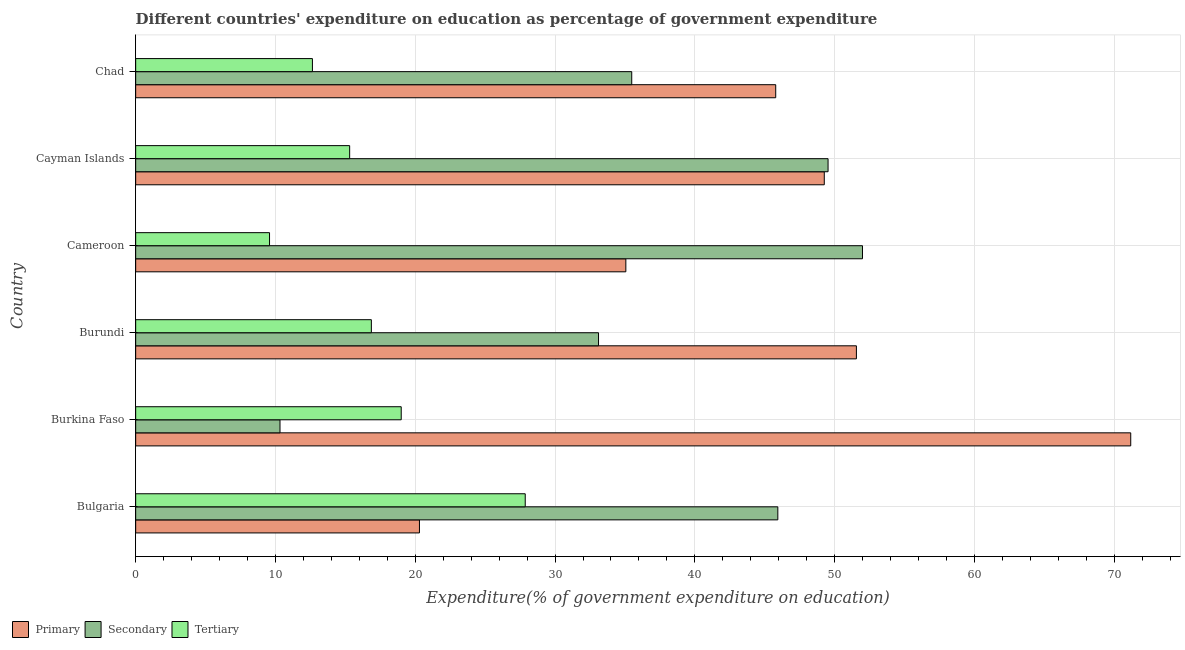Are the number of bars per tick equal to the number of legend labels?
Ensure brevity in your answer.  Yes. How many bars are there on the 6th tick from the top?
Keep it short and to the point. 3. What is the label of the 6th group of bars from the top?
Your response must be concise. Bulgaria. What is the expenditure on tertiary education in Chad?
Provide a short and direct response. 12.64. Across all countries, what is the maximum expenditure on secondary education?
Make the answer very short. 51.99. Across all countries, what is the minimum expenditure on secondary education?
Provide a succinct answer. 10.32. In which country was the expenditure on primary education maximum?
Offer a very short reply. Burkina Faso. What is the total expenditure on secondary education in the graph?
Give a very brief answer. 226.38. What is the difference between the expenditure on primary education in Bulgaria and that in Burundi?
Offer a terse response. -31.26. What is the difference between the expenditure on secondary education in Bulgaria and the expenditure on tertiary education in Cayman Islands?
Ensure brevity in your answer.  30.63. What is the average expenditure on tertiary education per country?
Provide a succinct answer. 16.88. What is the difference between the expenditure on secondary education and expenditure on tertiary education in Cameroon?
Give a very brief answer. 42.42. What is the ratio of the expenditure on tertiary education in Bulgaria to that in Burundi?
Give a very brief answer. 1.65. Is the expenditure on secondary education in Burundi less than that in Cameroon?
Your answer should be very brief. Yes. What is the difference between the highest and the second highest expenditure on secondary education?
Make the answer very short. 2.46. What is the difference between the highest and the lowest expenditure on primary education?
Make the answer very short. 50.88. Is the sum of the expenditure on secondary education in Bulgaria and Chad greater than the maximum expenditure on tertiary education across all countries?
Ensure brevity in your answer.  Yes. What does the 1st bar from the top in Cameroon represents?
Your answer should be very brief. Tertiary. What does the 3rd bar from the bottom in Cayman Islands represents?
Offer a very short reply. Tertiary. Does the graph contain grids?
Ensure brevity in your answer.  Yes. What is the title of the graph?
Your answer should be compact. Different countries' expenditure on education as percentage of government expenditure. What is the label or title of the X-axis?
Make the answer very short. Expenditure(% of government expenditure on education). What is the label or title of the Y-axis?
Provide a succinct answer. Country. What is the Expenditure(% of government expenditure on education) of Primary in Bulgaria?
Your answer should be very brief. 20.3. What is the Expenditure(% of government expenditure on education) of Secondary in Bulgaria?
Your answer should be very brief. 45.94. What is the Expenditure(% of government expenditure on education) of Tertiary in Bulgaria?
Provide a short and direct response. 27.87. What is the Expenditure(% of government expenditure on education) in Primary in Burkina Faso?
Your answer should be compact. 71.18. What is the Expenditure(% of government expenditure on education) of Secondary in Burkina Faso?
Offer a very short reply. 10.32. What is the Expenditure(% of government expenditure on education) of Tertiary in Burkina Faso?
Your response must be concise. 19. What is the Expenditure(% of government expenditure on education) in Primary in Burundi?
Offer a terse response. 51.56. What is the Expenditure(% of government expenditure on education) in Secondary in Burundi?
Your answer should be compact. 33.11. What is the Expenditure(% of government expenditure on education) in Tertiary in Burundi?
Make the answer very short. 16.86. What is the Expenditure(% of government expenditure on education) of Primary in Cameroon?
Keep it short and to the point. 35.06. What is the Expenditure(% of government expenditure on education) in Secondary in Cameroon?
Offer a very short reply. 51.99. What is the Expenditure(% of government expenditure on education) in Tertiary in Cameroon?
Your answer should be very brief. 9.58. What is the Expenditure(% of government expenditure on education) in Primary in Cayman Islands?
Provide a short and direct response. 49.26. What is the Expenditure(% of government expenditure on education) in Secondary in Cayman Islands?
Your response must be concise. 49.53. What is the Expenditure(% of government expenditure on education) in Tertiary in Cayman Islands?
Your response must be concise. 15.31. What is the Expenditure(% of government expenditure on education) in Primary in Chad?
Make the answer very short. 45.78. What is the Expenditure(% of government expenditure on education) of Secondary in Chad?
Ensure brevity in your answer.  35.48. What is the Expenditure(% of government expenditure on education) of Tertiary in Chad?
Offer a very short reply. 12.64. Across all countries, what is the maximum Expenditure(% of government expenditure on education) of Primary?
Your answer should be very brief. 71.18. Across all countries, what is the maximum Expenditure(% of government expenditure on education) in Secondary?
Keep it short and to the point. 51.99. Across all countries, what is the maximum Expenditure(% of government expenditure on education) in Tertiary?
Offer a very short reply. 27.87. Across all countries, what is the minimum Expenditure(% of government expenditure on education) in Primary?
Your response must be concise. 20.3. Across all countries, what is the minimum Expenditure(% of government expenditure on education) of Secondary?
Provide a short and direct response. 10.32. Across all countries, what is the minimum Expenditure(% of government expenditure on education) in Tertiary?
Make the answer very short. 9.58. What is the total Expenditure(% of government expenditure on education) in Primary in the graph?
Provide a short and direct response. 273.15. What is the total Expenditure(% of government expenditure on education) of Secondary in the graph?
Keep it short and to the point. 226.38. What is the total Expenditure(% of government expenditure on education) of Tertiary in the graph?
Make the answer very short. 101.25. What is the difference between the Expenditure(% of government expenditure on education) in Primary in Bulgaria and that in Burkina Faso?
Your answer should be very brief. -50.88. What is the difference between the Expenditure(% of government expenditure on education) in Secondary in Bulgaria and that in Burkina Faso?
Your answer should be very brief. 35.61. What is the difference between the Expenditure(% of government expenditure on education) in Tertiary in Bulgaria and that in Burkina Faso?
Keep it short and to the point. 8.87. What is the difference between the Expenditure(% of government expenditure on education) of Primary in Bulgaria and that in Burundi?
Offer a terse response. -31.26. What is the difference between the Expenditure(% of government expenditure on education) in Secondary in Bulgaria and that in Burundi?
Give a very brief answer. 12.83. What is the difference between the Expenditure(% of government expenditure on education) in Tertiary in Bulgaria and that in Burundi?
Your response must be concise. 11.01. What is the difference between the Expenditure(% of government expenditure on education) of Primary in Bulgaria and that in Cameroon?
Ensure brevity in your answer.  -14.76. What is the difference between the Expenditure(% of government expenditure on education) in Secondary in Bulgaria and that in Cameroon?
Your answer should be very brief. -6.06. What is the difference between the Expenditure(% of government expenditure on education) of Tertiary in Bulgaria and that in Cameroon?
Your answer should be very brief. 18.29. What is the difference between the Expenditure(% of government expenditure on education) in Primary in Bulgaria and that in Cayman Islands?
Provide a succinct answer. -28.96. What is the difference between the Expenditure(% of government expenditure on education) in Secondary in Bulgaria and that in Cayman Islands?
Provide a short and direct response. -3.59. What is the difference between the Expenditure(% of government expenditure on education) in Tertiary in Bulgaria and that in Cayman Islands?
Offer a terse response. 12.56. What is the difference between the Expenditure(% of government expenditure on education) in Primary in Bulgaria and that in Chad?
Offer a terse response. -25.48. What is the difference between the Expenditure(% of government expenditure on education) in Secondary in Bulgaria and that in Chad?
Offer a very short reply. 10.45. What is the difference between the Expenditure(% of government expenditure on education) of Tertiary in Bulgaria and that in Chad?
Offer a terse response. 15.22. What is the difference between the Expenditure(% of government expenditure on education) in Primary in Burkina Faso and that in Burundi?
Your answer should be compact. 19.62. What is the difference between the Expenditure(% of government expenditure on education) of Secondary in Burkina Faso and that in Burundi?
Ensure brevity in your answer.  -22.79. What is the difference between the Expenditure(% of government expenditure on education) in Tertiary in Burkina Faso and that in Burundi?
Your answer should be compact. 2.14. What is the difference between the Expenditure(% of government expenditure on education) of Primary in Burkina Faso and that in Cameroon?
Your answer should be very brief. 36.12. What is the difference between the Expenditure(% of government expenditure on education) in Secondary in Burkina Faso and that in Cameroon?
Give a very brief answer. -41.67. What is the difference between the Expenditure(% of government expenditure on education) in Tertiary in Burkina Faso and that in Cameroon?
Offer a terse response. 9.42. What is the difference between the Expenditure(% of government expenditure on education) of Primary in Burkina Faso and that in Cayman Islands?
Provide a short and direct response. 21.92. What is the difference between the Expenditure(% of government expenditure on education) in Secondary in Burkina Faso and that in Cayman Islands?
Your answer should be compact. -39.2. What is the difference between the Expenditure(% of government expenditure on education) of Tertiary in Burkina Faso and that in Cayman Islands?
Provide a succinct answer. 3.69. What is the difference between the Expenditure(% of government expenditure on education) of Primary in Burkina Faso and that in Chad?
Provide a succinct answer. 25.4. What is the difference between the Expenditure(% of government expenditure on education) in Secondary in Burkina Faso and that in Chad?
Your answer should be very brief. -25.16. What is the difference between the Expenditure(% of government expenditure on education) in Tertiary in Burkina Faso and that in Chad?
Your answer should be very brief. 6.35. What is the difference between the Expenditure(% of government expenditure on education) of Primary in Burundi and that in Cameroon?
Make the answer very short. 16.49. What is the difference between the Expenditure(% of government expenditure on education) of Secondary in Burundi and that in Cameroon?
Keep it short and to the point. -18.88. What is the difference between the Expenditure(% of government expenditure on education) in Tertiary in Burundi and that in Cameroon?
Keep it short and to the point. 7.28. What is the difference between the Expenditure(% of government expenditure on education) of Primary in Burundi and that in Cayman Islands?
Make the answer very short. 2.3. What is the difference between the Expenditure(% of government expenditure on education) in Secondary in Burundi and that in Cayman Islands?
Offer a terse response. -16.42. What is the difference between the Expenditure(% of government expenditure on education) of Tertiary in Burundi and that in Cayman Islands?
Your answer should be very brief. 1.55. What is the difference between the Expenditure(% of government expenditure on education) of Primary in Burundi and that in Chad?
Offer a terse response. 5.77. What is the difference between the Expenditure(% of government expenditure on education) in Secondary in Burundi and that in Chad?
Your response must be concise. -2.38. What is the difference between the Expenditure(% of government expenditure on education) in Tertiary in Burundi and that in Chad?
Your response must be concise. 4.22. What is the difference between the Expenditure(% of government expenditure on education) in Primary in Cameroon and that in Cayman Islands?
Offer a terse response. -14.19. What is the difference between the Expenditure(% of government expenditure on education) in Secondary in Cameroon and that in Cayman Islands?
Your answer should be very brief. 2.46. What is the difference between the Expenditure(% of government expenditure on education) of Tertiary in Cameroon and that in Cayman Islands?
Make the answer very short. -5.73. What is the difference between the Expenditure(% of government expenditure on education) of Primary in Cameroon and that in Chad?
Keep it short and to the point. -10.72. What is the difference between the Expenditure(% of government expenditure on education) of Secondary in Cameroon and that in Chad?
Offer a very short reply. 16.51. What is the difference between the Expenditure(% of government expenditure on education) in Tertiary in Cameroon and that in Chad?
Your answer should be very brief. -3.07. What is the difference between the Expenditure(% of government expenditure on education) of Primary in Cayman Islands and that in Chad?
Ensure brevity in your answer.  3.47. What is the difference between the Expenditure(% of government expenditure on education) in Secondary in Cayman Islands and that in Chad?
Give a very brief answer. 14.04. What is the difference between the Expenditure(% of government expenditure on education) in Tertiary in Cayman Islands and that in Chad?
Provide a succinct answer. 2.66. What is the difference between the Expenditure(% of government expenditure on education) of Primary in Bulgaria and the Expenditure(% of government expenditure on education) of Secondary in Burkina Faso?
Ensure brevity in your answer.  9.98. What is the difference between the Expenditure(% of government expenditure on education) in Primary in Bulgaria and the Expenditure(% of government expenditure on education) in Tertiary in Burkina Faso?
Give a very brief answer. 1.3. What is the difference between the Expenditure(% of government expenditure on education) in Secondary in Bulgaria and the Expenditure(% of government expenditure on education) in Tertiary in Burkina Faso?
Your answer should be very brief. 26.94. What is the difference between the Expenditure(% of government expenditure on education) in Primary in Bulgaria and the Expenditure(% of government expenditure on education) in Secondary in Burundi?
Provide a succinct answer. -12.81. What is the difference between the Expenditure(% of government expenditure on education) of Primary in Bulgaria and the Expenditure(% of government expenditure on education) of Tertiary in Burundi?
Offer a very short reply. 3.44. What is the difference between the Expenditure(% of government expenditure on education) of Secondary in Bulgaria and the Expenditure(% of government expenditure on education) of Tertiary in Burundi?
Your response must be concise. 29.08. What is the difference between the Expenditure(% of government expenditure on education) of Primary in Bulgaria and the Expenditure(% of government expenditure on education) of Secondary in Cameroon?
Give a very brief answer. -31.69. What is the difference between the Expenditure(% of government expenditure on education) in Primary in Bulgaria and the Expenditure(% of government expenditure on education) in Tertiary in Cameroon?
Your answer should be very brief. 10.72. What is the difference between the Expenditure(% of government expenditure on education) of Secondary in Bulgaria and the Expenditure(% of government expenditure on education) of Tertiary in Cameroon?
Your answer should be very brief. 36.36. What is the difference between the Expenditure(% of government expenditure on education) in Primary in Bulgaria and the Expenditure(% of government expenditure on education) in Secondary in Cayman Islands?
Your answer should be compact. -29.23. What is the difference between the Expenditure(% of government expenditure on education) of Primary in Bulgaria and the Expenditure(% of government expenditure on education) of Tertiary in Cayman Islands?
Your answer should be very brief. 4.99. What is the difference between the Expenditure(% of government expenditure on education) in Secondary in Bulgaria and the Expenditure(% of government expenditure on education) in Tertiary in Cayman Islands?
Provide a succinct answer. 30.63. What is the difference between the Expenditure(% of government expenditure on education) in Primary in Bulgaria and the Expenditure(% of government expenditure on education) in Secondary in Chad?
Your answer should be compact. -15.18. What is the difference between the Expenditure(% of government expenditure on education) of Primary in Bulgaria and the Expenditure(% of government expenditure on education) of Tertiary in Chad?
Your response must be concise. 7.66. What is the difference between the Expenditure(% of government expenditure on education) in Secondary in Bulgaria and the Expenditure(% of government expenditure on education) in Tertiary in Chad?
Provide a succinct answer. 33.29. What is the difference between the Expenditure(% of government expenditure on education) of Primary in Burkina Faso and the Expenditure(% of government expenditure on education) of Secondary in Burundi?
Offer a very short reply. 38.07. What is the difference between the Expenditure(% of government expenditure on education) in Primary in Burkina Faso and the Expenditure(% of government expenditure on education) in Tertiary in Burundi?
Ensure brevity in your answer.  54.32. What is the difference between the Expenditure(% of government expenditure on education) of Secondary in Burkina Faso and the Expenditure(% of government expenditure on education) of Tertiary in Burundi?
Make the answer very short. -6.53. What is the difference between the Expenditure(% of government expenditure on education) in Primary in Burkina Faso and the Expenditure(% of government expenditure on education) in Secondary in Cameroon?
Give a very brief answer. 19.19. What is the difference between the Expenditure(% of government expenditure on education) of Primary in Burkina Faso and the Expenditure(% of government expenditure on education) of Tertiary in Cameroon?
Provide a succinct answer. 61.61. What is the difference between the Expenditure(% of government expenditure on education) in Secondary in Burkina Faso and the Expenditure(% of government expenditure on education) in Tertiary in Cameroon?
Give a very brief answer. 0.75. What is the difference between the Expenditure(% of government expenditure on education) of Primary in Burkina Faso and the Expenditure(% of government expenditure on education) of Secondary in Cayman Islands?
Give a very brief answer. 21.65. What is the difference between the Expenditure(% of government expenditure on education) of Primary in Burkina Faso and the Expenditure(% of government expenditure on education) of Tertiary in Cayman Islands?
Provide a short and direct response. 55.87. What is the difference between the Expenditure(% of government expenditure on education) of Secondary in Burkina Faso and the Expenditure(% of government expenditure on education) of Tertiary in Cayman Islands?
Keep it short and to the point. -4.98. What is the difference between the Expenditure(% of government expenditure on education) in Primary in Burkina Faso and the Expenditure(% of government expenditure on education) in Secondary in Chad?
Your answer should be very brief. 35.7. What is the difference between the Expenditure(% of government expenditure on education) in Primary in Burkina Faso and the Expenditure(% of government expenditure on education) in Tertiary in Chad?
Give a very brief answer. 58.54. What is the difference between the Expenditure(% of government expenditure on education) of Secondary in Burkina Faso and the Expenditure(% of government expenditure on education) of Tertiary in Chad?
Make the answer very short. -2.32. What is the difference between the Expenditure(% of government expenditure on education) in Primary in Burundi and the Expenditure(% of government expenditure on education) in Secondary in Cameroon?
Your answer should be compact. -0.43. What is the difference between the Expenditure(% of government expenditure on education) of Primary in Burundi and the Expenditure(% of government expenditure on education) of Tertiary in Cameroon?
Ensure brevity in your answer.  41.98. What is the difference between the Expenditure(% of government expenditure on education) in Secondary in Burundi and the Expenditure(% of government expenditure on education) in Tertiary in Cameroon?
Make the answer very short. 23.53. What is the difference between the Expenditure(% of government expenditure on education) in Primary in Burundi and the Expenditure(% of government expenditure on education) in Secondary in Cayman Islands?
Offer a very short reply. 2.03. What is the difference between the Expenditure(% of government expenditure on education) of Primary in Burundi and the Expenditure(% of government expenditure on education) of Tertiary in Cayman Islands?
Keep it short and to the point. 36.25. What is the difference between the Expenditure(% of government expenditure on education) of Secondary in Burundi and the Expenditure(% of government expenditure on education) of Tertiary in Cayman Islands?
Offer a terse response. 17.8. What is the difference between the Expenditure(% of government expenditure on education) in Primary in Burundi and the Expenditure(% of government expenditure on education) in Secondary in Chad?
Offer a terse response. 16.07. What is the difference between the Expenditure(% of government expenditure on education) in Primary in Burundi and the Expenditure(% of government expenditure on education) in Tertiary in Chad?
Ensure brevity in your answer.  38.91. What is the difference between the Expenditure(% of government expenditure on education) in Secondary in Burundi and the Expenditure(% of government expenditure on education) in Tertiary in Chad?
Your answer should be very brief. 20.47. What is the difference between the Expenditure(% of government expenditure on education) in Primary in Cameroon and the Expenditure(% of government expenditure on education) in Secondary in Cayman Islands?
Offer a very short reply. -14.47. What is the difference between the Expenditure(% of government expenditure on education) of Primary in Cameroon and the Expenditure(% of government expenditure on education) of Tertiary in Cayman Islands?
Provide a short and direct response. 19.76. What is the difference between the Expenditure(% of government expenditure on education) in Secondary in Cameroon and the Expenditure(% of government expenditure on education) in Tertiary in Cayman Islands?
Provide a short and direct response. 36.68. What is the difference between the Expenditure(% of government expenditure on education) in Primary in Cameroon and the Expenditure(% of government expenditure on education) in Secondary in Chad?
Your answer should be very brief. -0.42. What is the difference between the Expenditure(% of government expenditure on education) in Primary in Cameroon and the Expenditure(% of government expenditure on education) in Tertiary in Chad?
Offer a terse response. 22.42. What is the difference between the Expenditure(% of government expenditure on education) in Secondary in Cameroon and the Expenditure(% of government expenditure on education) in Tertiary in Chad?
Your answer should be very brief. 39.35. What is the difference between the Expenditure(% of government expenditure on education) in Primary in Cayman Islands and the Expenditure(% of government expenditure on education) in Secondary in Chad?
Your answer should be very brief. 13.77. What is the difference between the Expenditure(% of government expenditure on education) of Primary in Cayman Islands and the Expenditure(% of government expenditure on education) of Tertiary in Chad?
Provide a short and direct response. 36.62. What is the difference between the Expenditure(% of government expenditure on education) in Secondary in Cayman Islands and the Expenditure(% of government expenditure on education) in Tertiary in Chad?
Make the answer very short. 36.89. What is the average Expenditure(% of government expenditure on education) of Primary per country?
Ensure brevity in your answer.  45.52. What is the average Expenditure(% of government expenditure on education) in Secondary per country?
Your response must be concise. 37.73. What is the average Expenditure(% of government expenditure on education) of Tertiary per country?
Ensure brevity in your answer.  16.87. What is the difference between the Expenditure(% of government expenditure on education) in Primary and Expenditure(% of government expenditure on education) in Secondary in Bulgaria?
Make the answer very short. -25.64. What is the difference between the Expenditure(% of government expenditure on education) of Primary and Expenditure(% of government expenditure on education) of Tertiary in Bulgaria?
Your response must be concise. -7.57. What is the difference between the Expenditure(% of government expenditure on education) in Secondary and Expenditure(% of government expenditure on education) in Tertiary in Bulgaria?
Ensure brevity in your answer.  18.07. What is the difference between the Expenditure(% of government expenditure on education) in Primary and Expenditure(% of government expenditure on education) in Secondary in Burkina Faso?
Offer a terse response. 60.86. What is the difference between the Expenditure(% of government expenditure on education) of Primary and Expenditure(% of government expenditure on education) of Tertiary in Burkina Faso?
Your answer should be very brief. 52.19. What is the difference between the Expenditure(% of government expenditure on education) in Secondary and Expenditure(% of government expenditure on education) in Tertiary in Burkina Faso?
Give a very brief answer. -8.67. What is the difference between the Expenditure(% of government expenditure on education) in Primary and Expenditure(% of government expenditure on education) in Secondary in Burundi?
Give a very brief answer. 18.45. What is the difference between the Expenditure(% of government expenditure on education) in Primary and Expenditure(% of government expenditure on education) in Tertiary in Burundi?
Provide a succinct answer. 34.7. What is the difference between the Expenditure(% of government expenditure on education) of Secondary and Expenditure(% of government expenditure on education) of Tertiary in Burundi?
Your response must be concise. 16.25. What is the difference between the Expenditure(% of government expenditure on education) of Primary and Expenditure(% of government expenditure on education) of Secondary in Cameroon?
Provide a short and direct response. -16.93. What is the difference between the Expenditure(% of government expenditure on education) in Primary and Expenditure(% of government expenditure on education) in Tertiary in Cameroon?
Your answer should be very brief. 25.49. What is the difference between the Expenditure(% of government expenditure on education) of Secondary and Expenditure(% of government expenditure on education) of Tertiary in Cameroon?
Ensure brevity in your answer.  42.42. What is the difference between the Expenditure(% of government expenditure on education) in Primary and Expenditure(% of government expenditure on education) in Secondary in Cayman Islands?
Offer a very short reply. -0.27. What is the difference between the Expenditure(% of government expenditure on education) of Primary and Expenditure(% of government expenditure on education) of Tertiary in Cayman Islands?
Make the answer very short. 33.95. What is the difference between the Expenditure(% of government expenditure on education) in Secondary and Expenditure(% of government expenditure on education) in Tertiary in Cayman Islands?
Your answer should be very brief. 34.22. What is the difference between the Expenditure(% of government expenditure on education) in Primary and Expenditure(% of government expenditure on education) in Secondary in Chad?
Offer a terse response. 10.3. What is the difference between the Expenditure(% of government expenditure on education) of Primary and Expenditure(% of government expenditure on education) of Tertiary in Chad?
Your answer should be compact. 33.14. What is the difference between the Expenditure(% of government expenditure on education) in Secondary and Expenditure(% of government expenditure on education) in Tertiary in Chad?
Ensure brevity in your answer.  22.84. What is the ratio of the Expenditure(% of government expenditure on education) of Primary in Bulgaria to that in Burkina Faso?
Your answer should be compact. 0.29. What is the ratio of the Expenditure(% of government expenditure on education) in Secondary in Bulgaria to that in Burkina Faso?
Make the answer very short. 4.45. What is the ratio of the Expenditure(% of government expenditure on education) of Tertiary in Bulgaria to that in Burkina Faso?
Provide a short and direct response. 1.47. What is the ratio of the Expenditure(% of government expenditure on education) of Primary in Bulgaria to that in Burundi?
Make the answer very short. 0.39. What is the ratio of the Expenditure(% of government expenditure on education) of Secondary in Bulgaria to that in Burundi?
Provide a succinct answer. 1.39. What is the ratio of the Expenditure(% of government expenditure on education) in Tertiary in Bulgaria to that in Burundi?
Offer a very short reply. 1.65. What is the ratio of the Expenditure(% of government expenditure on education) in Primary in Bulgaria to that in Cameroon?
Your answer should be very brief. 0.58. What is the ratio of the Expenditure(% of government expenditure on education) of Secondary in Bulgaria to that in Cameroon?
Provide a succinct answer. 0.88. What is the ratio of the Expenditure(% of government expenditure on education) of Tertiary in Bulgaria to that in Cameroon?
Make the answer very short. 2.91. What is the ratio of the Expenditure(% of government expenditure on education) in Primary in Bulgaria to that in Cayman Islands?
Offer a terse response. 0.41. What is the ratio of the Expenditure(% of government expenditure on education) in Secondary in Bulgaria to that in Cayman Islands?
Your answer should be compact. 0.93. What is the ratio of the Expenditure(% of government expenditure on education) of Tertiary in Bulgaria to that in Cayman Islands?
Give a very brief answer. 1.82. What is the ratio of the Expenditure(% of government expenditure on education) of Primary in Bulgaria to that in Chad?
Your response must be concise. 0.44. What is the ratio of the Expenditure(% of government expenditure on education) of Secondary in Bulgaria to that in Chad?
Ensure brevity in your answer.  1.29. What is the ratio of the Expenditure(% of government expenditure on education) in Tertiary in Bulgaria to that in Chad?
Provide a succinct answer. 2.2. What is the ratio of the Expenditure(% of government expenditure on education) in Primary in Burkina Faso to that in Burundi?
Provide a succinct answer. 1.38. What is the ratio of the Expenditure(% of government expenditure on education) in Secondary in Burkina Faso to that in Burundi?
Your answer should be very brief. 0.31. What is the ratio of the Expenditure(% of government expenditure on education) in Tertiary in Burkina Faso to that in Burundi?
Offer a very short reply. 1.13. What is the ratio of the Expenditure(% of government expenditure on education) of Primary in Burkina Faso to that in Cameroon?
Offer a very short reply. 2.03. What is the ratio of the Expenditure(% of government expenditure on education) of Secondary in Burkina Faso to that in Cameroon?
Keep it short and to the point. 0.2. What is the ratio of the Expenditure(% of government expenditure on education) in Tertiary in Burkina Faso to that in Cameroon?
Provide a succinct answer. 1.98. What is the ratio of the Expenditure(% of government expenditure on education) of Primary in Burkina Faso to that in Cayman Islands?
Your answer should be compact. 1.45. What is the ratio of the Expenditure(% of government expenditure on education) in Secondary in Burkina Faso to that in Cayman Islands?
Keep it short and to the point. 0.21. What is the ratio of the Expenditure(% of government expenditure on education) in Tertiary in Burkina Faso to that in Cayman Islands?
Make the answer very short. 1.24. What is the ratio of the Expenditure(% of government expenditure on education) of Primary in Burkina Faso to that in Chad?
Ensure brevity in your answer.  1.55. What is the ratio of the Expenditure(% of government expenditure on education) of Secondary in Burkina Faso to that in Chad?
Provide a succinct answer. 0.29. What is the ratio of the Expenditure(% of government expenditure on education) of Tertiary in Burkina Faso to that in Chad?
Your answer should be compact. 1.5. What is the ratio of the Expenditure(% of government expenditure on education) in Primary in Burundi to that in Cameroon?
Ensure brevity in your answer.  1.47. What is the ratio of the Expenditure(% of government expenditure on education) in Secondary in Burundi to that in Cameroon?
Offer a very short reply. 0.64. What is the ratio of the Expenditure(% of government expenditure on education) of Tertiary in Burundi to that in Cameroon?
Offer a terse response. 1.76. What is the ratio of the Expenditure(% of government expenditure on education) in Primary in Burundi to that in Cayman Islands?
Your answer should be compact. 1.05. What is the ratio of the Expenditure(% of government expenditure on education) in Secondary in Burundi to that in Cayman Islands?
Ensure brevity in your answer.  0.67. What is the ratio of the Expenditure(% of government expenditure on education) of Tertiary in Burundi to that in Cayman Islands?
Make the answer very short. 1.1. What is the ratio of the Expenditure(% of government expenditure on education) of Primary in Burundi to that in Chad?
Offer a very short reply. 1.13. What is the ratio of the Expenditure(% of government expenditure on education) in Secondary in Burundi to that in Chad?
Ensure brevity in your answer.  0.93. What is the ratio of the Expenditure(% of government expenditure on education) in Tertiary in Burundi to that in Chad?
Your answer should be compact. 1.33. What is the ratio of the Expenditure(% of government expenditure on education) of Primary in Cameroon to that in Cayman Islands?
Provide a succinct answer. 0.71. What is the ratio of the Expenditure(% of government expenditure on education) in Secondary in Cameroon to that in Cayman Islands?
Keep it short and to the point. 1.05. What is the ratio of the Expenditure(% of government expenditure on education) in Tertiary in Cameroon to that in Cayman Islands?
Offer a very short reply. 0.63. What is the ratio of the Expenditure(% of government expenditure on education) of Primary in Cameroon to that in Chad?
Your response must be concise. 0.77. What is the ratio of the Expenditure(% of government expenditure on education) in Secondary in Cameroon to that in Chad?
Keep it short and to the point. 1.47. What is the ratio of the Expenditure(% of government expenditure on education) in Tertiary in Cameroon to that in Chad?
Your response must be concise. 0.76. What is the ratio of the Expenditure(% of government expenditure on education) in Primary in Cayman Islands to that in Chad?
Make the answer very short. 1.08. What is the ratio of the Expenditure(% of government expenditure on education) in Secondary in Cayman Islands to that in Chad?
Ensure brevity in your answer.  1.4. What is the ratio of the Expenditure(% of government expenditure on education) of Tertiary in Cayman Islands to that in Chad?
Your answer should be compact. 1.21. What is the difference between the highest and the second highest Expenditure(% of government expenditure on education) in Primary?
Offer a terse response. 19.62. What is the difference between the highest and the second highest Expenditure(% of government expenditure on education) in Secondary?
Offer a terse response. 2.46. What is the difference between the highest and the second highest Expenditure(% of government expenditure on education) of Tertiary?
Give a very brief answer. 8.87. What is the difference between the highest and the lowest Expenditure(% of government expenditure on education) in Primary?
Provide a succinct answer. 50.88. What is the difference between the highest and the lowest Expenditure(% of government expenditure on education) in Secondary?
Your response must be concise. 41.67. What is the difference between the highest and the lowest Expenditure(% of government expenditure on education) of Tertiary?
Make the answer very short. 18.29. 